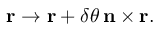<formula> <loc_0><loc_0><loc_500><loc_500>r \rightarrow r + \delta \theta \, n \times r .</formula> 